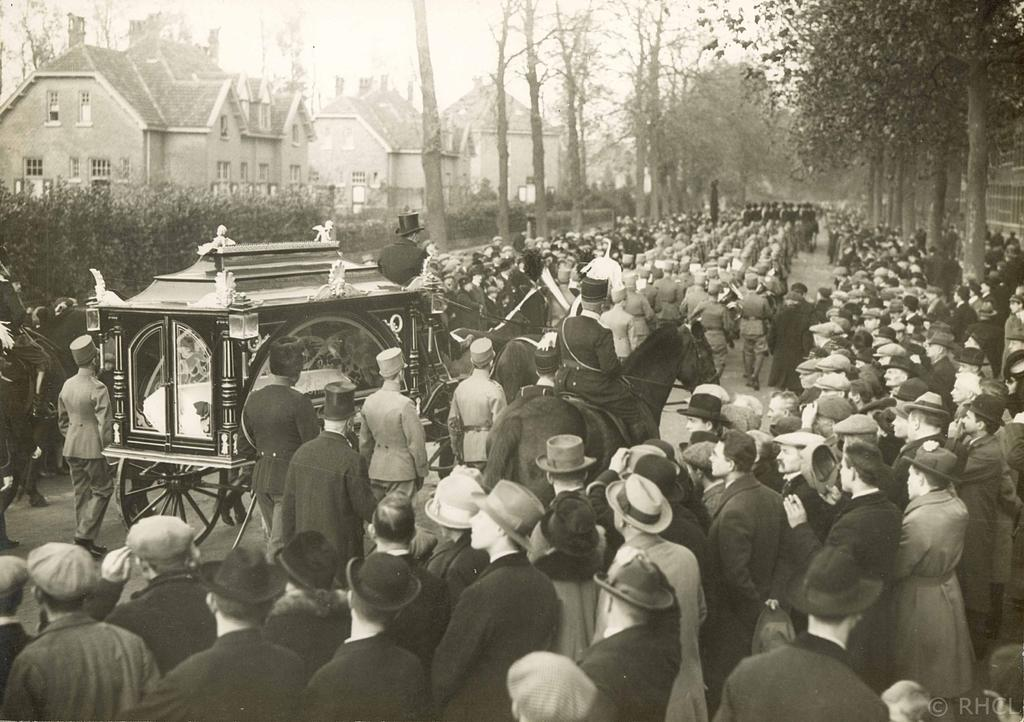What is the main focus of the image? The main focus of the image is the many people in the center. What can be seen in the background of the image? There are houses and trees in the background of the image. What type of soda is being served at the event in the image? There is no event or soda present in the image; it features a group of people and a background with houses and trees. What type of collar is visible on the people in the image? There are no collars visible on the people in the image; they are not wearing any clothing that would have collars. 